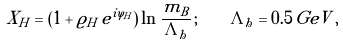Convert formula to latex. <formula><loc_0><loc_0><loc_500><loc_500>X _ { H } = \left ( 1 + \varrho _ { H } \, e ^ { i \varphi _ { H } } \right ) \ln \frac { m _ { B } } { \Lambda _ { h } } \, ; \quad \Lambda _ { h } = 0 . 5 \, G e V \, ,</formula> 